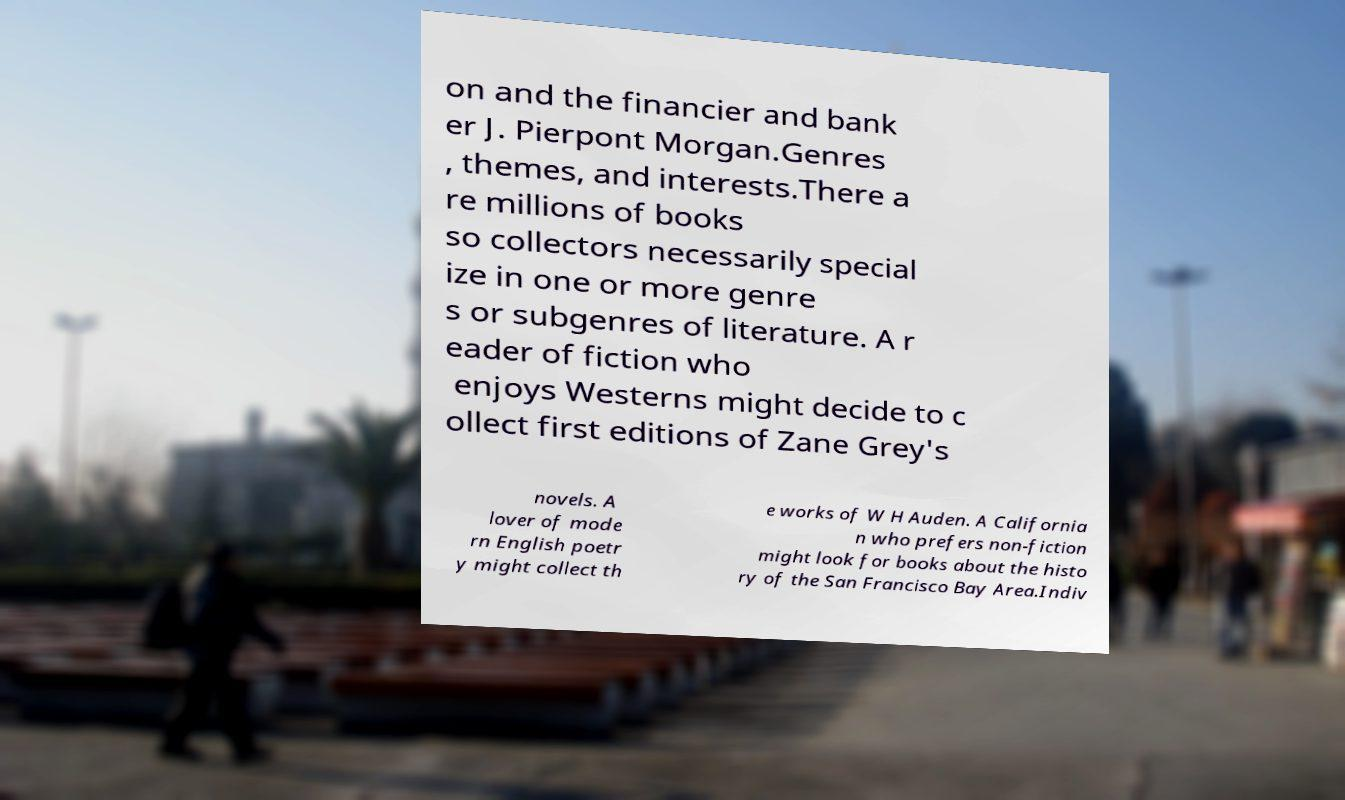Could you extract and type out the text from this image? on and the financier and bank er J. Pierpont Morgan.Genres , themes, and interests.There a re millions of books so collectors necessarily special ize in one or more genre s or subgenres of literature. A r eader of fiction who enjoys Westerns might decide to c ollect first editions of Zane Grey's novels. A lover of mode rn English poetr y might collect th e works of W H Auden. A California n who prefers non-fiction might look for books about the histo ry of the San Francisco Bay Area.Indiv 